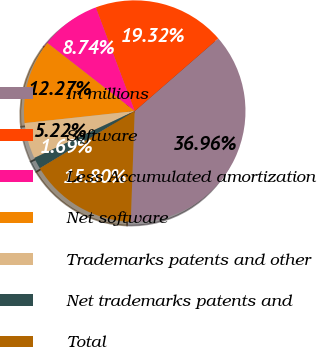Convert chart to OTSL. <chart><loc_0><loc_0><loc_500><loc_500><pie_chart><fcel>In millions<fcel>Software<fcel>Less Accumulated amortization<fcel>Net software<fcel>Trademarks patents and other<fcel>Net trademarks patents and<fcel>Total<nl><fcel>36.96%<fcel>19.32%<fcel>8.74%<fcel>12.27%<fcel>5.22%<fcel>1.69%<fcel>15.8%<nl></chart> 